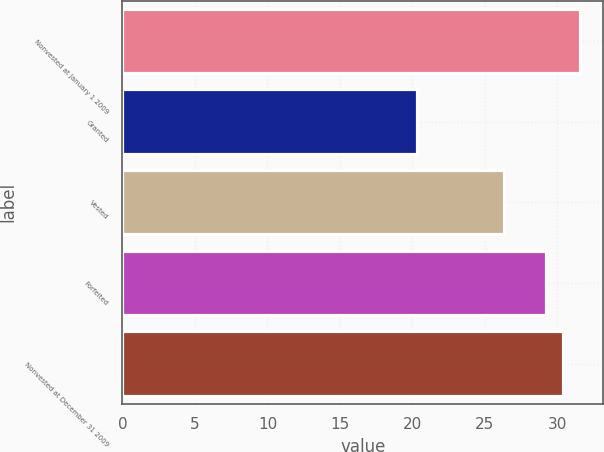<chart> <loc_0><loc_0><loc_500><loc_500><bar_chart><fcel>Nonvested at January 1 2009<fcel>Granted<fcel>Vested<fcel>Forfeited<fcel>Nonvested at December 31 2009<nl><fcel>31.57<fcel>20.34<fcel>26.32<fcel>29.24<fcel>30.36<nl></chart> 